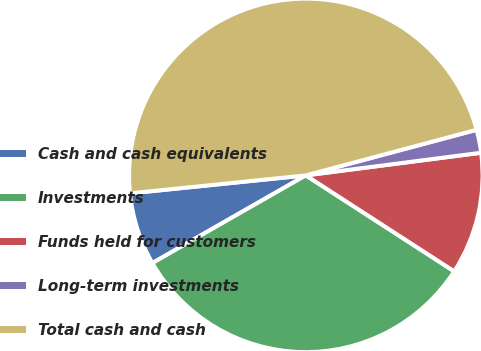<chart> <loc_0><loc_0><loc_500><loc_500><pie_chart><fcel>Cash and cash equivalents<fcel>Investments<fcel>Funds held for customers<fcel>Long-term investments<fcel>Total cash and cash<nl><fcel>6.64%<fcel>32.6%<fcel>11.18%<fcel>2.11%<fcel>47.47%<nl></chart> 